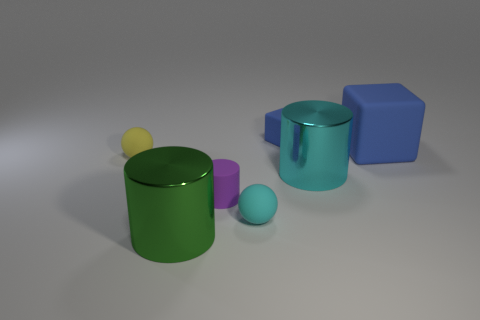There is another rubber thing that is the same shape as the tiny cyan rubber thing; what is its color? yellow 